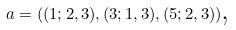Convert formula to latex. <formula><loc_0><loc_0><loc_500><loc_500>a = ( ( 1 ; 2 , 3 ) , ( 3 ; 1 , 3 ) , ( 5 ; 2 , 3 ) ) \text {,}</formula> 